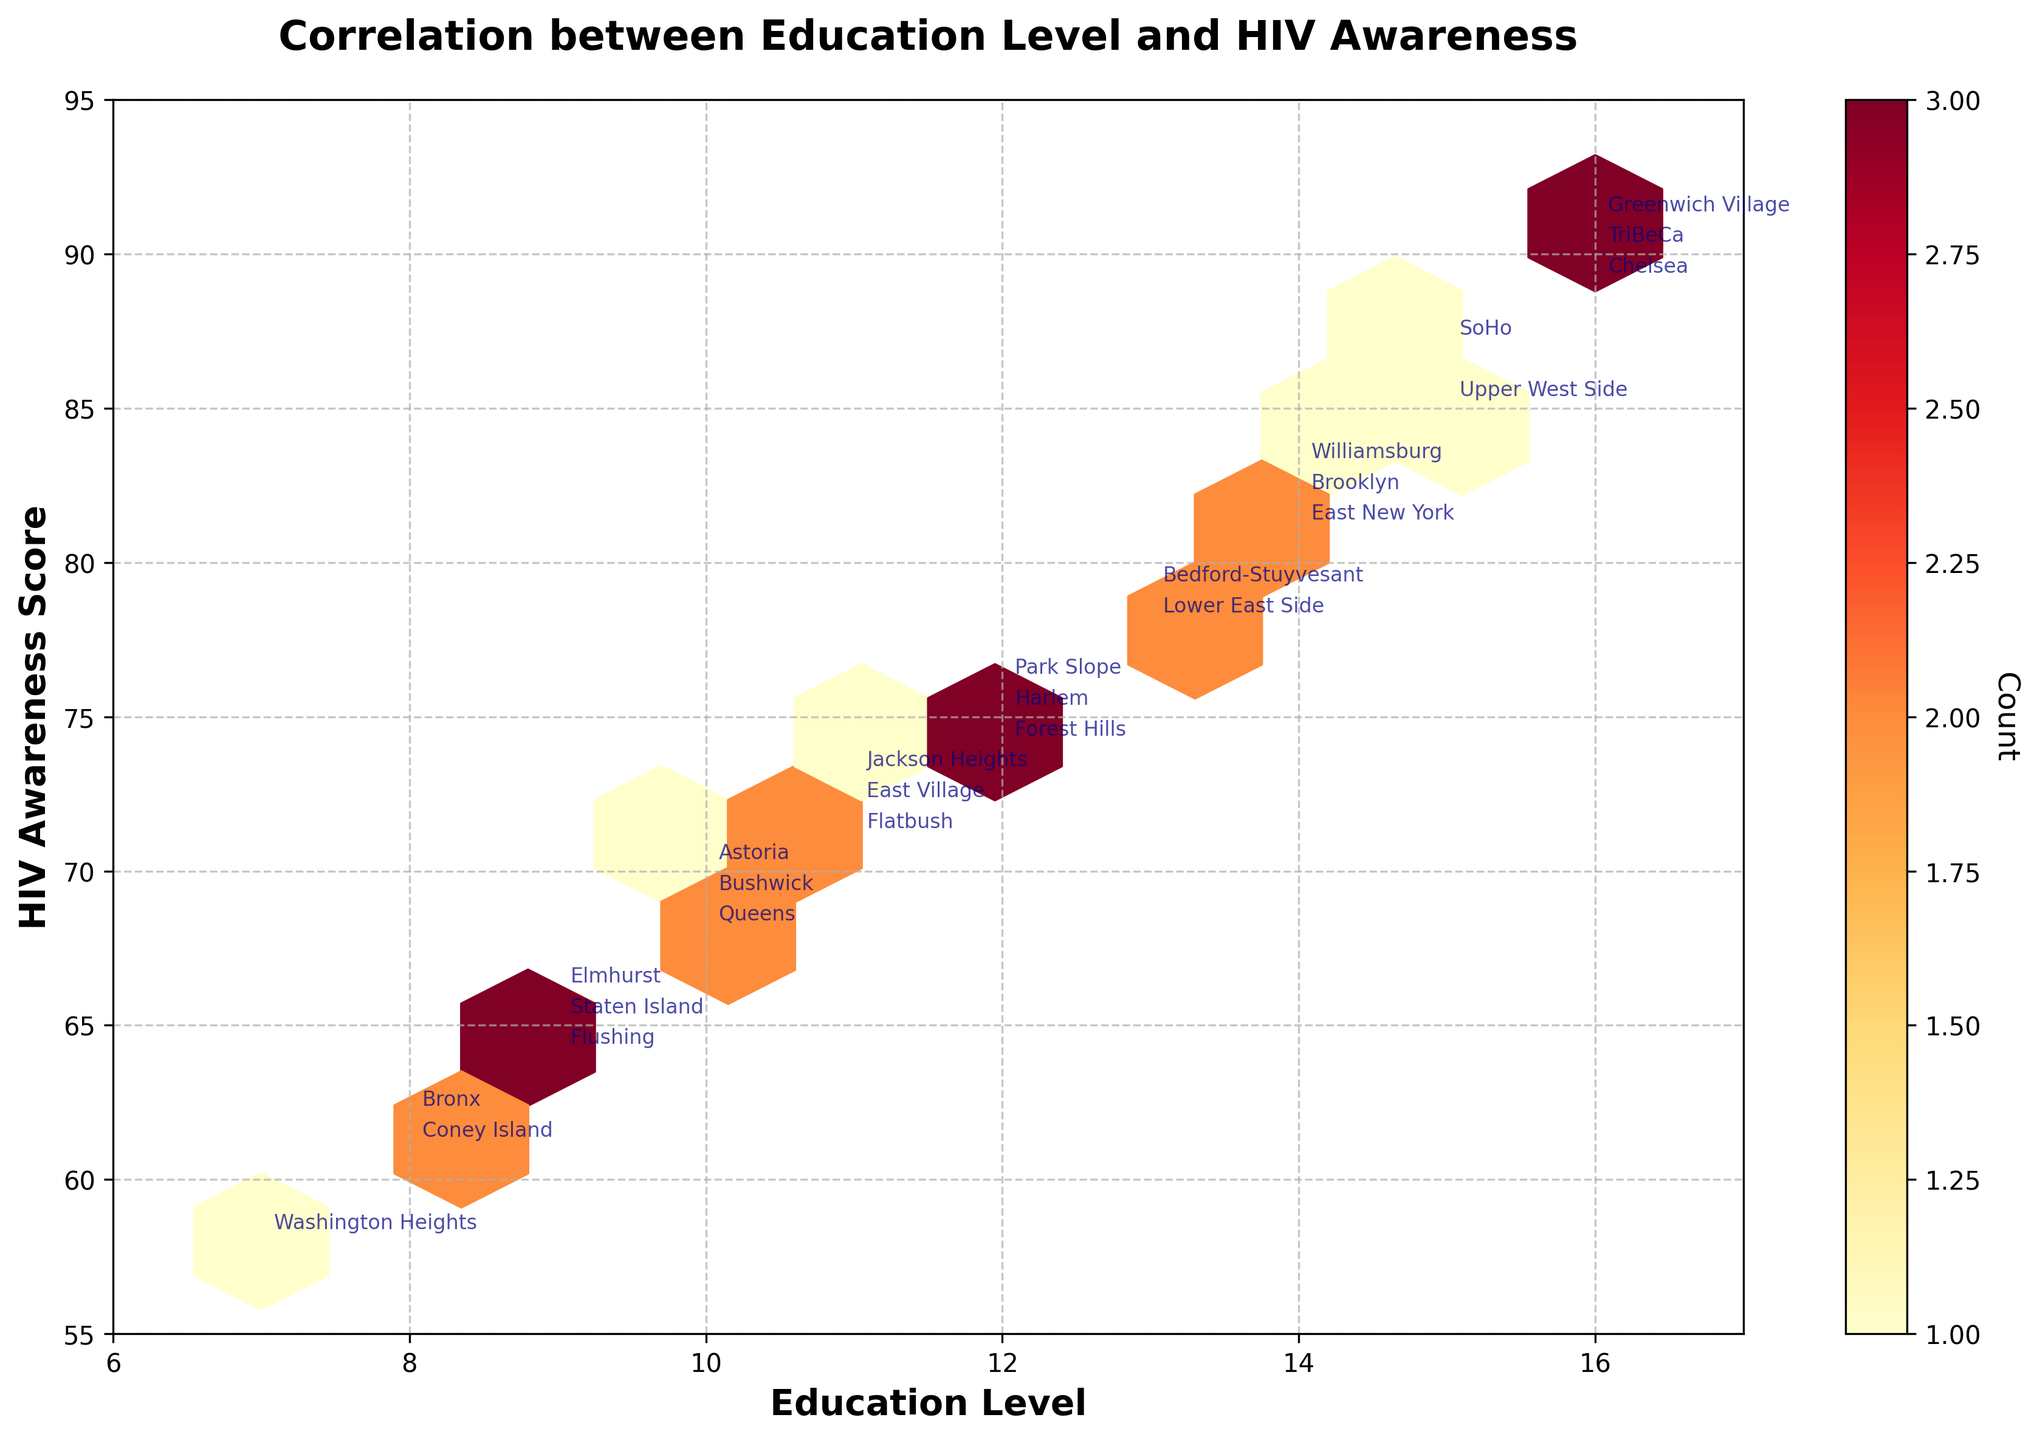What is the title of the plot? The title of the plot is usually placed at the top, in this case, it reads 'Correlation between Education Level and HIV Awareness'.
Answer: Correlation between Education Level and HIV Awareness What are the x and y axes representing? The x-axis is labeled 'Education Level' and the y-axis is labeled 'HIV Awareness Score'.
Answer: Education Level and HIV Awareness Score What is the range of the x-axis? By observing the x-axis, it is clear that the range is from 6 to 17.
Answer: 6 to 17 Which community has the highest HIV awareness score? Look at the data points and annotations, identify the highest y-value. Greenwich Village shows the highest score of 91.
Answer: Greenwich Village What color represents the highest density of data points? The hexbin plot typically uses a color gradient, with lighter colors representing fewer points and darker colors representing higher density. The darkest color, which represents the highest density, is closest to red in this plot.
Answer: Red Is there a visible positive correlation between education level and HIV awareness score? By examining the overall trend of the data points from left to right, we can see that as the education level increases, the HIV awareness score also increases.
Answer: Yes Which community has the lowest HIV awareness score and what is it? Identify the lowest y-value among the annotated points. Washington Heights has the lowest score of 58.
Answer: Washington Heights, 58 How many data points have an education level of 16? Find data points on the x-axis at 16 and observe how many hexagons are present. There are three such communities: Chelsea, Greenwich Village, and TriBeCa.
Answer: 3 What is the average HIV awareness score for communities with an education level of 12? Identify the HIV awareness scores for communities with an education level of 12: 75, 76, 74. Calculate the average: (75 + 76 + 74) / 3 = 225 / 3 = 75.
Answer: 75 Do more communities fall within the education level range 9-11 or 13-15? Count the number of hexagons for education levels 9, 10, and 11 (total: 7), and for 13, 14, and 15 (total: 6). Compare the counts.
Answer: 9-11 